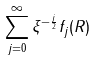<formula> <loc_0><loc_0><loc_500><loc_500>\sum _ { j = 0 } ^ { \infty } \xi ^ { - \frac { j } 2 } f _ { j } ( R )</formula> 